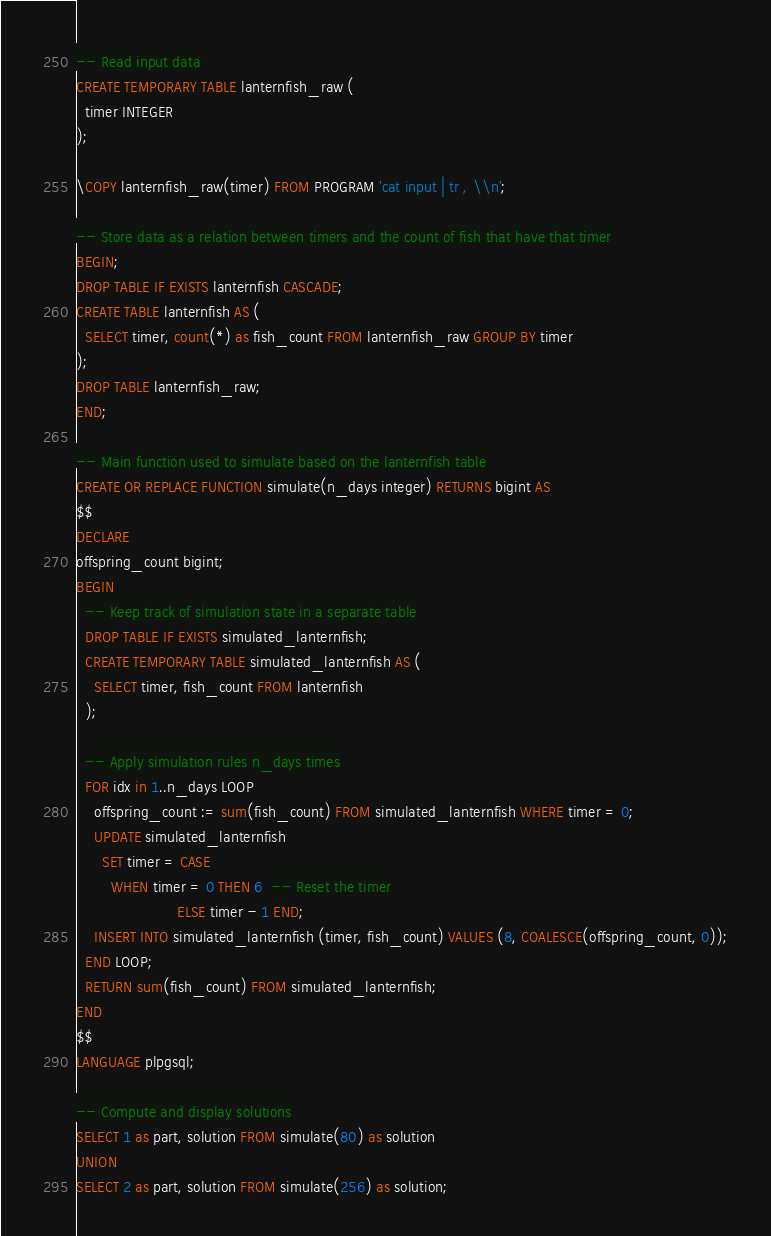Convert code to text. <code><loc_0><loc_0><loc_500><loc_500><_SQL_>-- Read input data
CREATE TEMPORARY TABLE lanternfish_raw (
  timer INTEGER
);

\COPY lanternfish_raw(timer) FROM PROGRAM 'cat input | tr , \\n';

-- Store data as a relation between timers and the count of fish that have that timer
BEGIN;
DROP TABLE IF EXISTS lanternfish CASCADE;
CREATE TABLE lanternfish AS (
  SELECT timer, count(*) as fish_count FROM lanternfish_raw GROUP BY timer
);
DROP TABLE lanternfish_raw;
END;

-- Main function used to simulate based on the lanternfish table
CREATE OR REPLACE FUNCTION simulate(n_days integer) RETURNS bigint AS
$$
DECLARE
offspring_count bigint;
BEGIN
  -- Keep track of simulation state in a separate table
  DROP TABLE IF EXISTS simulated_lanternfish;
  CREATE TEMPORARY TABLE simulated_lanternfish AS (
    SELECT timer, fish_count FROM lanternfish
  );

  -- Apply simulation rules n_days times
  FOR idx in 1..n_days LOOP
    offspring_count := sum(fish_count) FROM simulated_lanternfish WHERE timer = 0;
    UPDATE simulated_lanternfish
      SET timer = CASE
        WHEN timer = 0 THEN 6  -- Reset the timer
                       ELSE timer - 1 END;
    INSERT INTO simulated_lanternfish (timer, fish_count) VALUES (8, COALESCE(offspring_count, 0));
  END LOOP;
  RETURN sum(fish_count) FROM simulated_lanternfish;
END
$$
LANGUAGE plpgsql;

-- Compute and display solutions
SELECT 1 as part, solution FROM simulate(80) as solution
UNION
SELECT 2 as part, solution FROM simulate(256) as solution;
</code> 